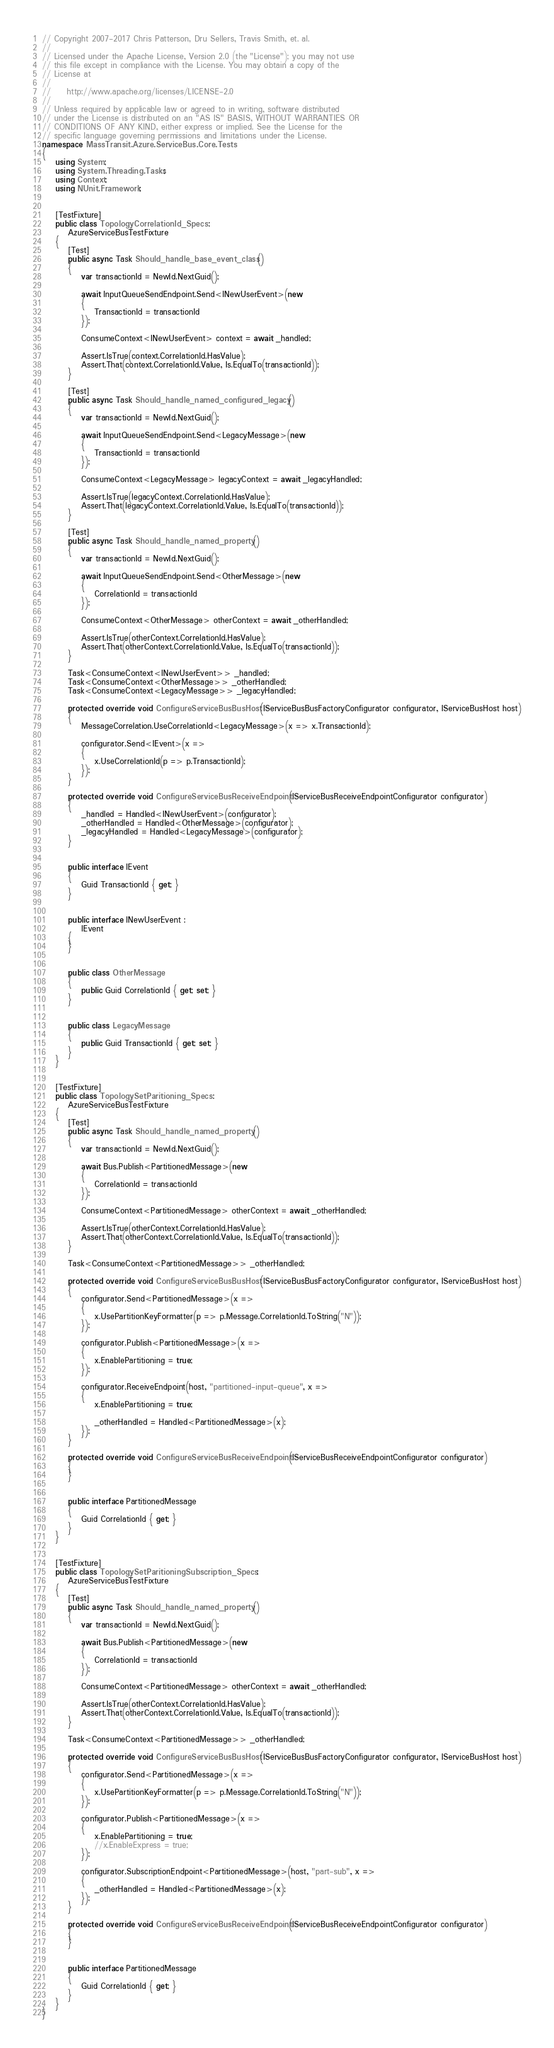<code> <loc_0><loc_0><loc_500><loc_500><_C#_>// Copyright 2007-2017 Chris Patterson, Dru Sellers, Travis Smith, et. al.
//  
// Licensed under the Apache License, Version 2.0 (the "License"); you may not use
// this file except in compliance with the License. You may obtain a copy of the 
// License at 
// 
//     http://www.apache.org/licenses/LICENSE-2.0 
// 
// Unless required by applicable law or agreed to in writing, software distributed
// under the License is distributed on an "AS IS" BASIS, WITHOUT WARRANTIES OR 
// CONDITIONS OF ANY KIND, either express or implied. See the License for the 
// specific language governing permissions and limitations under the License.
namespace MassTransit.Azure.ServiceBus.Core.Tests
{
    using System;
    using System.Threading.Tasks;
    using Context;
    using NUnit.Framework;


    [TestFixture]
    public class TopologyCorrelationId_Specs :
        AzureServiceBusTestFixture
    {
        [Test]
        public async Task Should_handle_base_event_class()
        {
            var transactionId = NewId.NextGuid();

            await InputQueueSendEndpoint.Send<INewUserEvent>(new
            {
                TransactionId = transactionId
            });

            ConsumeContext<INewUserEvent> context = await _handled;

            Assert.IsTrue(context.CorrelationId.HasValue);
            Assert.That(context.CorrelationId.Value, Is.EqualTo(transactionId));
        }

        [Test]
        public async Task Should_handle_named_configured_legacy()
        {
            var transactionId = NewId.NextGuid();

            await InputQueueSendEndpoint.Send<LegacyMessage>(new
            {
                TransactionId = transactionId
            });

            ConsumeContext<LegacyMessage> legacyContext = await _legacyHandled;

            Assert.IsTrue(legacyContext.CorrelationId.HasValue);
            Assert.That(legacyContext.CorrelationId.Value, Is.EqualTo(transactionId));
        }

        [Test]
        public async Task Should_handle_named_property()
        {
            var transactionId = NewId.NextGuid();

            await InputQueueSendEndpoint.Send<OtherMessage>(new
            {
                CorrelationId = transactionId
            });

            ConsumeContext<OtherMessage> otherContext = await _otherHandled;

            Assert.IsTrue(otherContext.CorrelationId.HasValue);
            Assert.That(otherContext.CorrelationId.Value, Is.EqualTo(transactionId));
        }

        Task<ConsumeContext<INewUserEvent>> _handled;
        Task<ConsumeContext<OtherMessage>> _otherHandled;
        Task<ConsumeContext<LegacyMessage>> _legacyHandled;

        protected override void ConfigureServiceBusBusHost(IServiceBusBusFactoryConfigurator configurator, IServiceBusHost host)
        {
            MessageCorrelation.UseCorrelationId<LegacyMessage>(x => x.TransactionId);

            configurator.Send<IEvent>(x =>
            {
                x.UseCorrelationId(p => p.TransactionId);
            });
        }

        protected override void ConfigureServiceBusReceiveEndpoint(IServiceBusReceiveEndpointConfigurator configurator)
        {
            _handled = Handled<INewUserEvent>(configurator);
            _otherHandled = Handled<OtherMessage>(configurator);
            _legacyHandled = Handled<LegacyMessage>(configurator);
        }


        public interface IEvent
        {
            Guid TransactionId { get; }
        }


        public interface INewUserEvent :
            IEvent
        {
        }


        public class OtherMessage
        {
            public Guid CorrelationId { get; set; }
        }


        public class LegacyMessage
        {
            public Guid TransactionId { get; set; }
        }
    }


    [TestFixture]
    public class TopologySetParitioning_Specs :
        AzureServiceBusTestFixture
    {
        [Test]
        public async Task Should_handle_named_property()
        {
            var transactionId = NewId.NextGuid();

            await Bus.Publish<PartitionedMessage>(new
            {
                CorrelationId = transactionId
            });

            ConsumeContext<PartitionedMessage> otherContext = await _otherHandled;

            Assert.IsTrue(otherContext.CorrelationId.HasValue);
            Assert.That(otherContext.CorrelationId.Value, Is.EqualTo(transactionId));
        }

        Task<ConsumeContext<PartitionedMessage>> _otherHandled;

        protected override void ConfigureServiceBusBusHost(IServiceBusBusFactoryConfigurator configurator, IServiceBusHost host)
        {
            configurator.Send<PartitionedMessage>(x =>
            {
                x.UsePartitionKeyFormatter(p => p.Message.CorrelationId.ToString("N"));
            });

            configurator.Publish<PartitionedMessage>(x =>
            {
                x.EnablePartitioning = true;
            });

            configurator.ReceiveEndpoint(host, "partitioned-input-queue", x =>
            {
                x.EnablePartitioning = true;

                _otherHandled = Handled<PartitionedMessage>(x);
            });
        }

        protected override void ConfigureServiceBusReceiveEndpoint(IServiceBusReceiveEndpointConfigurator configurator)
        {
        }


        public interface PartitionedMessage
        {
            Guid CorrelationId { get; }
        }
    }


    [TestFixture]
    public class TopologySetParitioningSubscription_Specs :
        AzureServiceBusTestFixture
    {
        [Test]
        public async Task Should_handle_named_property()
        {
            var transactionId = NewId.NextGuid();

            await Bus.Publish<PartitionedMessage>(new
            {
                CorrelationId = transactionId
            });

            ConsumeContext<PartitionedMessage> otherContext = await _otherHandled;

            Assert.IsTrue(otherContext.CorrelationId.HasValue);
            Assert.That(otherContext.CorrelationId.Value, Is.EqualTo(transactionId));
        }

        Task<ConsumeContext<PartitionedMessage>> _otherHandled;

        protected override void ConfigureServiceBusBusHost(IServiceBusBusFactoryConfigurator configurator, IServiceBusHost host)
        {
            configurator.Send<PartitionedMessage>(x =>
            {
                x.UsePartitionKeyFormatter(p => p.Message.CorrelationId.ToString("N"));
            });

            configurator.Publish<PartitionedMessage>(x =>
            {
                x.EnablePartitioning = true;
                //x.EnableExpress = true;
            });

            configurator.SubscriptionEndpoint<PartitionedMessage>(host, "part-sub", x =>
            {
                _otherHandled = Handled<PartitionedMessage>(x);
            });
        }

        protected override void ConfigureServiceBusReceiveEndpoint(IServiceBusReceiveEndpointConfigurator configurator)
        {
        }


        public interface PartitionedMessage
        {
            Guid CorrelationId { get; }
        }
    }
}</code> 